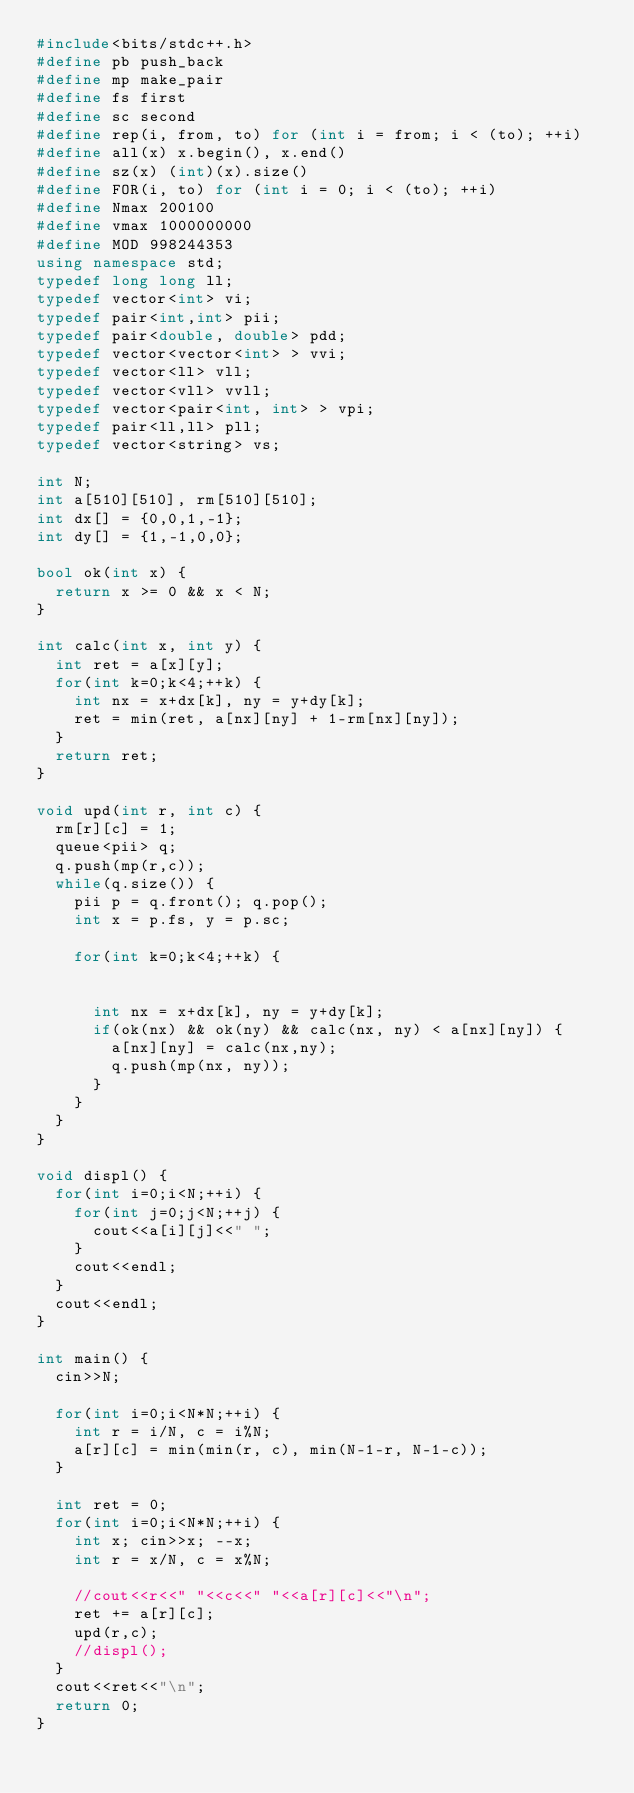Convert code to text. <code><loc_0><loc_0><loc_500><loc_500><_C++_>#include<bits/stdc++.h>
#define pb push_back
#define mp make_pair
#define fs first
#define sc second
#define rep(i, from, to) for (int i = from; i < (to); ++i)
#define all(x) x.begin(), x.end()
#define sz(x) (int)(x).size()
#define FOR(i, to) for (int i = 0; i < (to); ++i)
#define Nmax 200100
#define vmax 1000000000
#define MOD 998244353
using namespace std;
typedef long long ll;
typedef vector<int> vi;
typedef pair<int,int> pii;
typedef pair<double, double> pdd;
typedef vector<vector<int> > vvi;
typedef vector<ll> vll;
typedef vector<vll> vvll;
typedef vector<pair<int, int> > vpi;
typedef pair<ll,ll> pll;
typedef vector<string> vs;
 
int N;
int a[510][510], rm[510][510];
int dx[] = {0,0,1,-1};
int dy[] = {1,-1,0,0};
 
bool ok(int x) {
  return x >= 0 && x < N;
}

int calc(int x, int y) {
  int ret = a[x][y];
  for(int k=0;k<4;++k) {
    int nx = x+dx[k], ny = y+dy[k];
    ret = min(ret, a[nx][ny] + 1-rm[nx][ny]);
  }
  return ret;
}
 
void upd(int r, int c) {
  rm[r][c] = 1;
  queue<pii> q;
  q.push(mp(r,c));
  while(q.size()) {
    pii p = q.front(); q.pop();
    int x = p.fs, y = p.sc;
    
    for(int k=0;k<4;++k) {
    
    
      int nx = x+dx[k], ny = y+dy[k];
      if(ok(nx) && ok(ny) && calc(nx, ny) < a[nx][ny]) {
        a[nx][ny] = calc(nx,ny);
        q.push(mp(nx, ny));
      }
    }
  }
}
 
void displ() {
  for(int i=0;i<N;++i) {
    for(int j=0;j<N;++j) {
      cout<<a[i][j]<<" ";
    }
    cout<<endl;
  }
  cout<<endl;
}
 
int main() {
  cin>>N;
  
  for(int i=0;i<N*N;++i) {
    int r = i/N, c = i%N;
    a[r][c] = min(min(r, c), min(N-1-r, N-1-c));
  }
 
  int ret = 0;
  for(int i=0;i<N*N;++i) {
    int x; cin>>x; --x;
    int r = x/N, c = x%N;
    
    //cout<<r<<" "<<c<<" "<<a[r][c]<<"\n";
    ret += a[r][c];
    upd(r,c);
    //displ();
  }
  cout<<ret<<"\n";
  return 0;
}</code> 